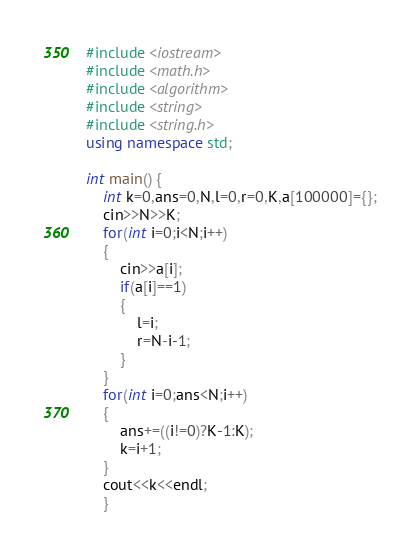Convert code to text. <code><loc_0><loc_0><loc_500><loc_500><_C++_>#include <iostream>
#include <math.h>
#include <algorithm>
#include <string>
#include <string.h>
using namespace std;

int main() {
	int k=0,ans=0,N,l=0,r=0,K,a[100000]={};
	cin>>N>>K;
	for(int i=0;i<N;i++)
	{
		cin>>a[i];
		if(a[i]==1)
		{
			l=i;
			r=N-i-1;
		}
	}
	for(int i=0;ans<N;i++)
	{
		ans+=((i!=0)?K-1:K);
		k=i+1;
	}
	cout<<k<<endl;
	}</code> 